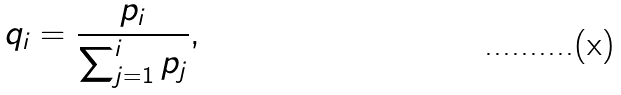<formula> <loc_0><loc_0><loc_500><loc_500>q _ { i } = \frac { p _ { i } } { \sum _ { j = 1 } ^ { i } p _ { j } } ,</formula> 